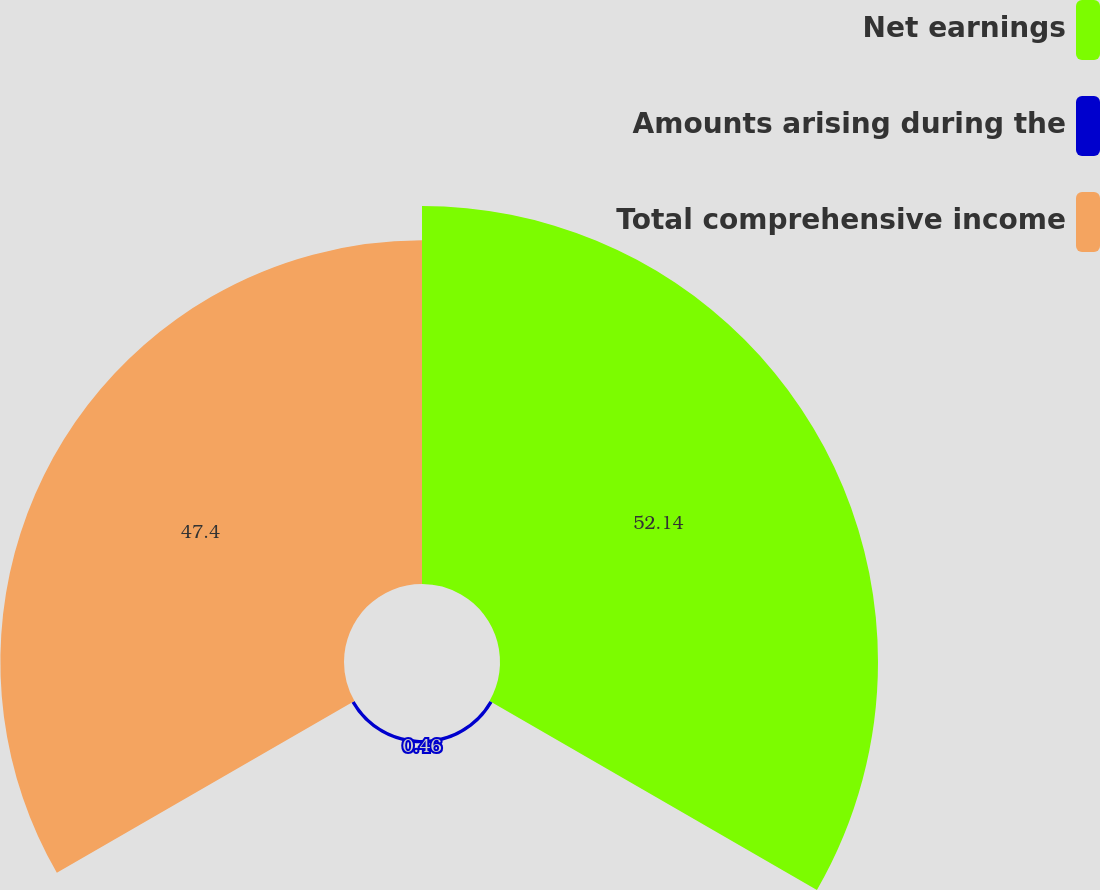Convert chart to OTSL. <chart><loc_0><loc_0><loc_500><loc_500><pie_chart><fcel>Net earnings<fcel>Amounts arising during the<fcel>Total comprehensive income<nl><fcel>52.14%<fcel>0.46%<fcel>47.4%<nl></chart> 